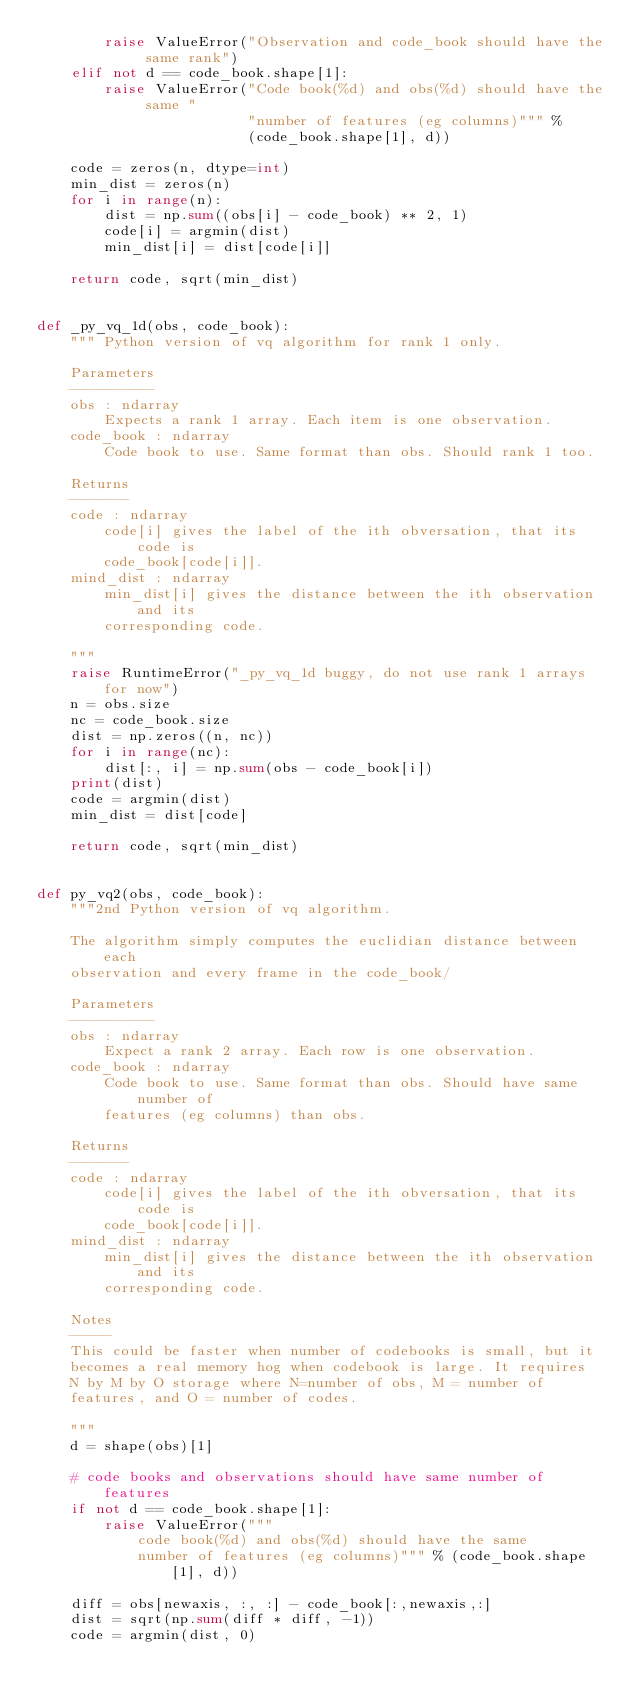<code> <loc_0><loc_0><loc_500><loc_500><_Python_>        raise ValueError("Observation and code_book should have the same rank")
    elif not d == code_book.shape[1]:
        raise ValueError("Code book(%d) and obs(%d) should have the same "
                         "number of features (eg columns)""" %
                         (code_book.shape[1], d))

    code = zeros(n, dtype=int)
    min_dist = zeros(n)
    for i in range(n):
        dist = np.sum((obs[i] - code_book) ** 2, 1)
        code[i] = argmin(dist)
        min_dist[i] = dist[code[i]]

    return code, sqrt(min_dist)


def _py_vq_1d(obs, code_book):
    """ Python version of vq algorithm for rank 1 only.

    Parameters
    ----------
    obs : ndarray
        Expects a rank 1 array. Each item is one observation.
    code_book : ndarray
        Code book to use. Same format than obs. Should rank 1 too.

    Returns
    -------
    code : ndarray
        code[i] gives the label of the ith obversation, that its code is
        code_book[code[i]].
    mind_dist : ndarray
        min_dist[i] gives the distance between the ith observation and its
        corresponding code.

    """
    raise RuntimeError("_py_vq_1d buggy, do not use rank 1 arrays for now")
    n = obs.size
    nc = code_book.size
    dist = np.zeros((n, nc))
    for i in range(nc):
        dist[:, i] = np.sum(obs - code_book[i])
    print(dist)
    code = argmin(dist)
    min_dist = dist[code]

    return code, sqrt(min_dist)


def py_vq2(obs, code_book):
    """2nd Python version of vq algorithm.

    The algorithm simply computes the euclidian distance between each
    observation and every frame in the code_book/

    Parameters
    ----------
    obs : ndarray
        Expect a rank 2 array. Each row is one observation.
    code_book : ndarray
        Code book to use. Same format than obs. Should have same number of
        features (eg columns) than obs.

    Returns
    -------
    code : ndarray
        code[i] gives the label of the ith obversation, that its code is
        code_book[code[i]].
    mind_dist : ndarray
        min_dist[i] gives the distance between the ith observation and its
        corresponding code.

    Notes
    -----
    This could be faster when number of codebooks is small, but it
    becomes a real memory hog when codebook is large. It requires
    N by M by O storage where N=number of obs, M = number of
    features, and O = number of codes.

    """
    d = shape(obs)[1]

    # code books and observations should have same number of features
    if not d == code_book.shape[1]:
        raise ValueError("""
            code book(%d) and obs(%d) should have the same
            number of features (eg columns)""" % (code_book.shape[1], d))

    diff = obs[newaxis, :, :] - code_book[:,newaxis,:]
    dist = sqrt(np.sum(diff * diff, -1))
    code = argmin(dist, 0)</code> 